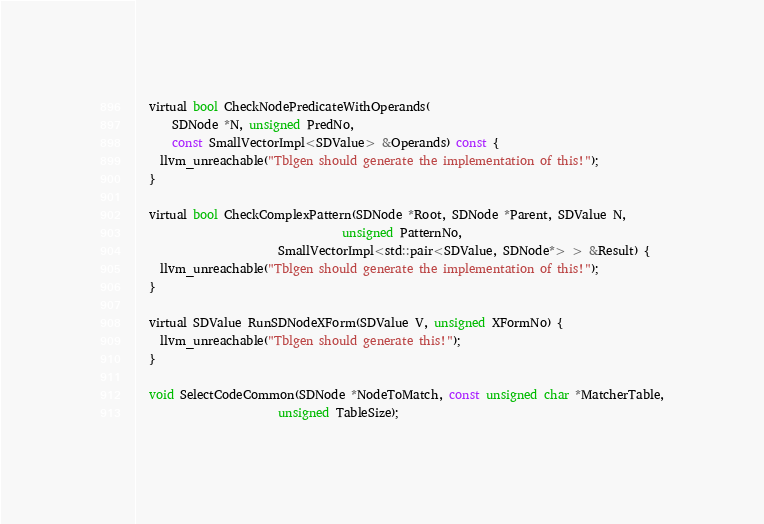<code> <loc_0><loc_0><loc_500><loc_500><_C_>  virtual bool CheckNodePredicateWithOperands(
      SDNode *N, unsigned PredNo,
      const SmallVectorImpl<SDValue> &Operands) const {
    llvm_unreachable("Tblgen should generate the implementation of this!");
  }

  virtual bool CheckComplexPattern(SDNode *Root, SDNode *Parent, SDValue N,
                                   unsigned PatternNo,
                        SmallVectorImpl<std::pair<SDValue, SDNode*> > &Result) {
    llvm_unreachable("Tblgen should generate the implementation of this!");
  }

  virtual SDValue RunSDNodeXForm(SDValue V, unsigned XFormNo) {
    llvm_unreachable("Tblgen should generate this!");
  }

  void SelectCodeCommon(SDNode *NodeToMatch, const unsigned char *MatcherTable,
                        unsigned TableSize);
</code> 